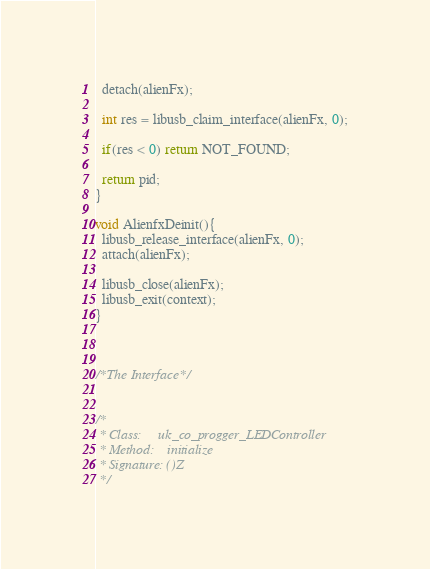Convert code to text. <code><loc_0><loc_0><loc_500><loc_500><_C++_>  detach(alienFx);

  int res = libusb_claim_interface(alienFx, 0);

  if(res < 0) return NOT_FOUND;

  return pid;
}

void AlienfxDeinit(){
  libusb_release_interface(alienFx, 0);
  attach(alienFx);
  
  libusb_close(alienFx);
  libusb_exit(context);
}



/*The Interface*/


/*
 * Class:     uk_co_progger_LEDController
 * Method:    initialize
 * Signature: ()Z
 */</code> 